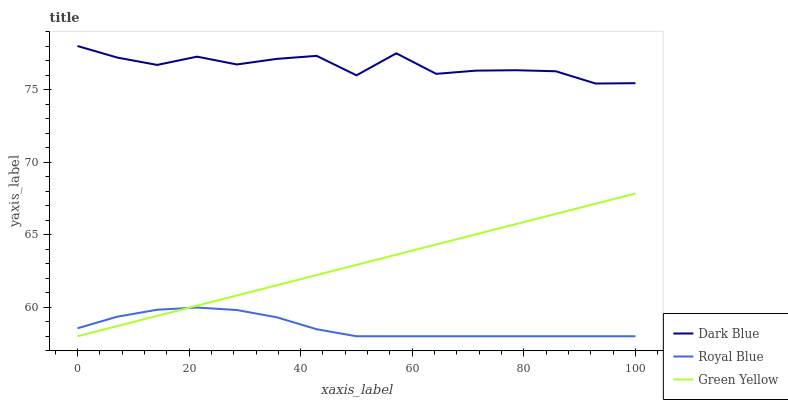Does Royal Blue have the minimum area under the curve?
Answer yes or no. Yes. Does Dark Blue have the maximum area under the curve?
Answer yes or no. Yes. Does Green Yellow have the minimum area under the curve?
Answer yes or no. No. Does Green Yellow have the maximum area under the curve?
Answer yes or no. No. Is Green Yellow the smoothest?
Answer yes or no. Yes. Is Dark Blue the roughest?
Answer yes or no. Yes. Is Royal Blue the smoothest?
Answer yes or no. No. Is Royal Blue the roughest?
Answer yes or no. No. Does Green Yellow have the lowest value?
Answer yes or no. Yes. Does Dark Blue have the highest value?
Answer yes or no. Yes. Does Green Yellow have the highest value?
Answer yes or no. No. Is Royal Blue less than Dark Blue?
Answer yes or no. Yes. Is Dark Blue greater than Green Yellow?
Answer yes or no. Yes. Does Royal Blue intersect Green Yellow?
Answer yes or no. Yes. Is Royal Blue less than Green Yellow?
Answer yes or no. No. Is Royal Blue greater than Green Yellow?
Answer yes or no. No. Does Royal Blue intersect Dark Blue?
Answer yes or no. No. 